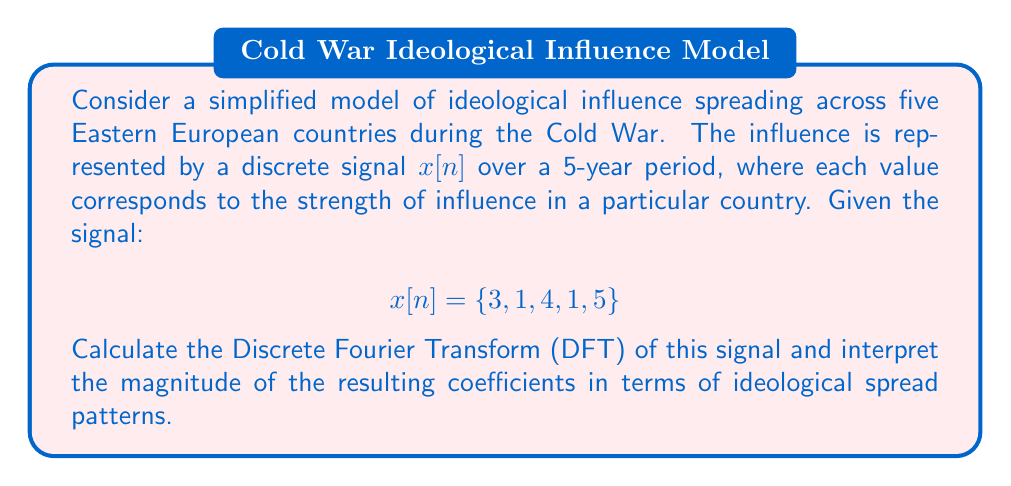Teach me how to tackle this problem. To solve this problem, we'll follow these steps:

1) The N-point DFT is defined as:

   $$X[k] = \sum_{n=0}^{N-1} x[n] e^{-j2\pi kn/N}$$

   where $N = 5$ in this case.

2) We need to calculate $X[k]$ for $k = 0, 1, 2, 3, 4$:

   $$X[k] = 3e^{-j2\pi k0/5} + 1e^{-j2\pi k1/5} + 4e^{-j2\pi k2/5} + 1e^{-j2\pi k3/5} + 5e^{-j2\pi k4/5}$$

3) Let's calculate each coefficient:

   For $k = 0$:
   $$X[0] = 3 + 1 + 4 + 1 + 5 = 14$$

   For $k = 1$:
   $$X[1] = 3 + 1e^{-j2\pi/5} + 4e^{-j4\pi/5} + 1e^{-j6\pi/5} + 5e^{-j8\pi/5} \approx 2.62 - 4.05j$$

   For $k = 2$:
   $$X[2] = 3 + 1e^{-j4\pi/5} + 4e^{-j8\pi/5} + 1e^{-j12\pi/5} + 5e^{-j16\pi/5} \approx -3.62 + 0.56j$$

   For $k = 3$:
   $$X[3] = 3 + 1e^{-j6\pi/5} + 4e^{-j12\pi/5} + 1e^{-j18\pi/5} + 5e^{-j24\pi/5} \approx -3.62 - 0.56j$$

   For $k = 4$:
   $$X[4] = 3 + 1e^{-j8\pi/5} + 4e^{-j16\pi/5} + 1e^{-j24\pi/5} + 5e^{-j32\pi/5} \approx 2.62 + 4.05j$$

4) To interpret the magnitude of these coefficients:

   $|X[0]| = 14$ represents the average influence across all countries.
   $|X[1]| = |X[4]| \approx 4.83$ represents the strength of the yearly cycle of influence.
   $|X[2]| = |X[3]| \approx 3.66$ represents the strength of the half-yearly cycle of influence.

The larger magnitude of $|X[1]|$ and $|X[4]|$ compared to $|X[2]|$ and $|X[3]|$ suggests that the yearly pattern of ideological influence is stronger than the half-yearly pattern, which could indicate annual cycles in propaganda or policy changes affecting the spread of ideology.
Answer: The DFT coefficients are:

$$X[0] = 14$$
$$X[1] \approx 2.62 - 4.05j$$
$$X[2] \approx -3.62 + 0.56j$$
$$X[3] \approx -3.62 - 0.56j$$
$$X[4] \approx 2.62 + 4.05j$$

Interpretation: The larger magnitude of the yearly cycle coefficients ($|X[1]| = |X[4]| \approx 4.83$) compared to the half-yearly cycle coefficients ($|X[2]| = |X[3]| \approx 3.66$) suggests that annual patterns were more significant in the spread of ideological influence across these Eastern European countries during the analyzed period. 